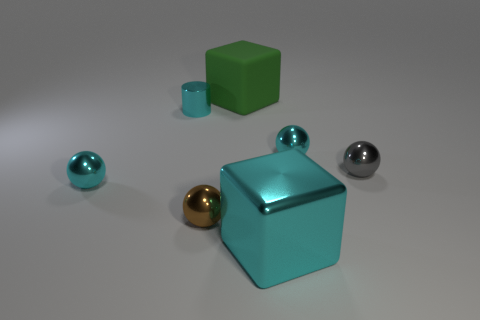What colors are the objects in the image? The objects include a green and a teal cube, a teal sphere, a metallic gray sphere, and a metallic gold sphere. Do any of the objects have a reflective surface? Yes, the teal cube, teal sphere, metallic gray sphere, and metallic gold sphere all have reflective surfaces. 